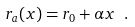<formula> <loc_0><loc_0><loc_500><loc_500>r _ { a } ( x ) = r _ { 0 } + \alpha x \ .</formula> 